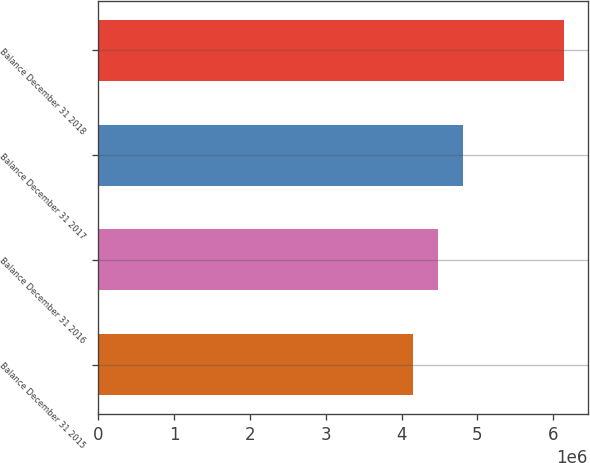Convert chart to OTSL. <chart><loc_0><loc_0><loc_500><loc_500><bar_chart><fcel>Balance December 31 2015<fcel>Balance December 31 2016<fcel>Balance December 31 2017<fcel>Balance December 31 2018<nl><fcel>4.14991e+06<fcel>4.47567e+06<fcel>4.80821e+06<fcel>6.14632e+06<nl></chart> 